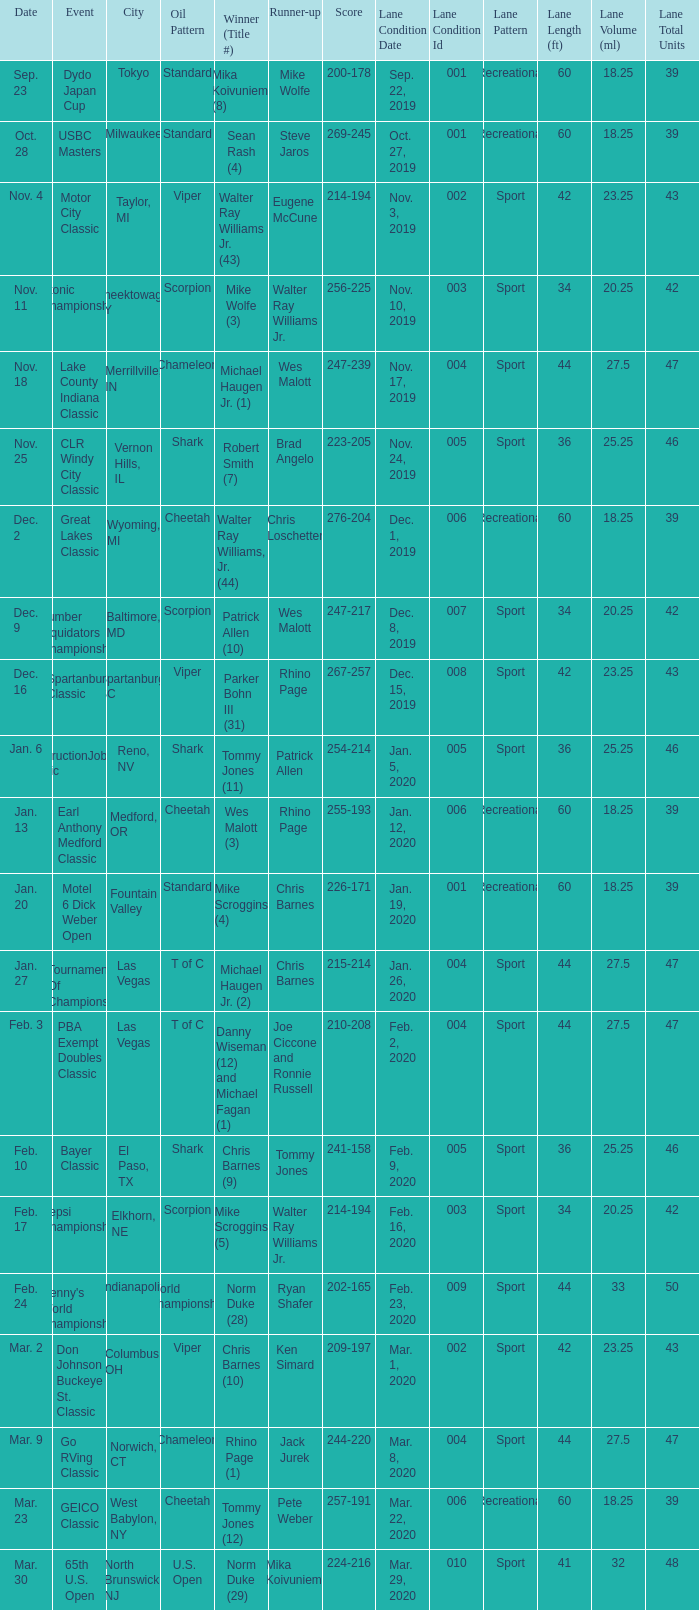Name the Date when has  robert smith (7)? Nov. 25. 